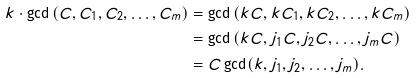<formula> <loc_0><loc_0><loc_500><loc_500>k \cdot \gcd \left ( C , C _ { 1 } , C _ { 2 } , \dots , C _ { m } \right ) & = \gcd \left ( k C , k C _ { 1 } , k C _ { 2 } , \dots , k C _ { m } \right ) \\ & = \gcd \left ( k C , j _ { 1 } C , j _ { 2 } C , \dots , j _ { m } C \right ) \\ & = C \gcd ( k , j _ { 1 } , j _ { 2 } , \dots , j _ { m } ) .</formula> 